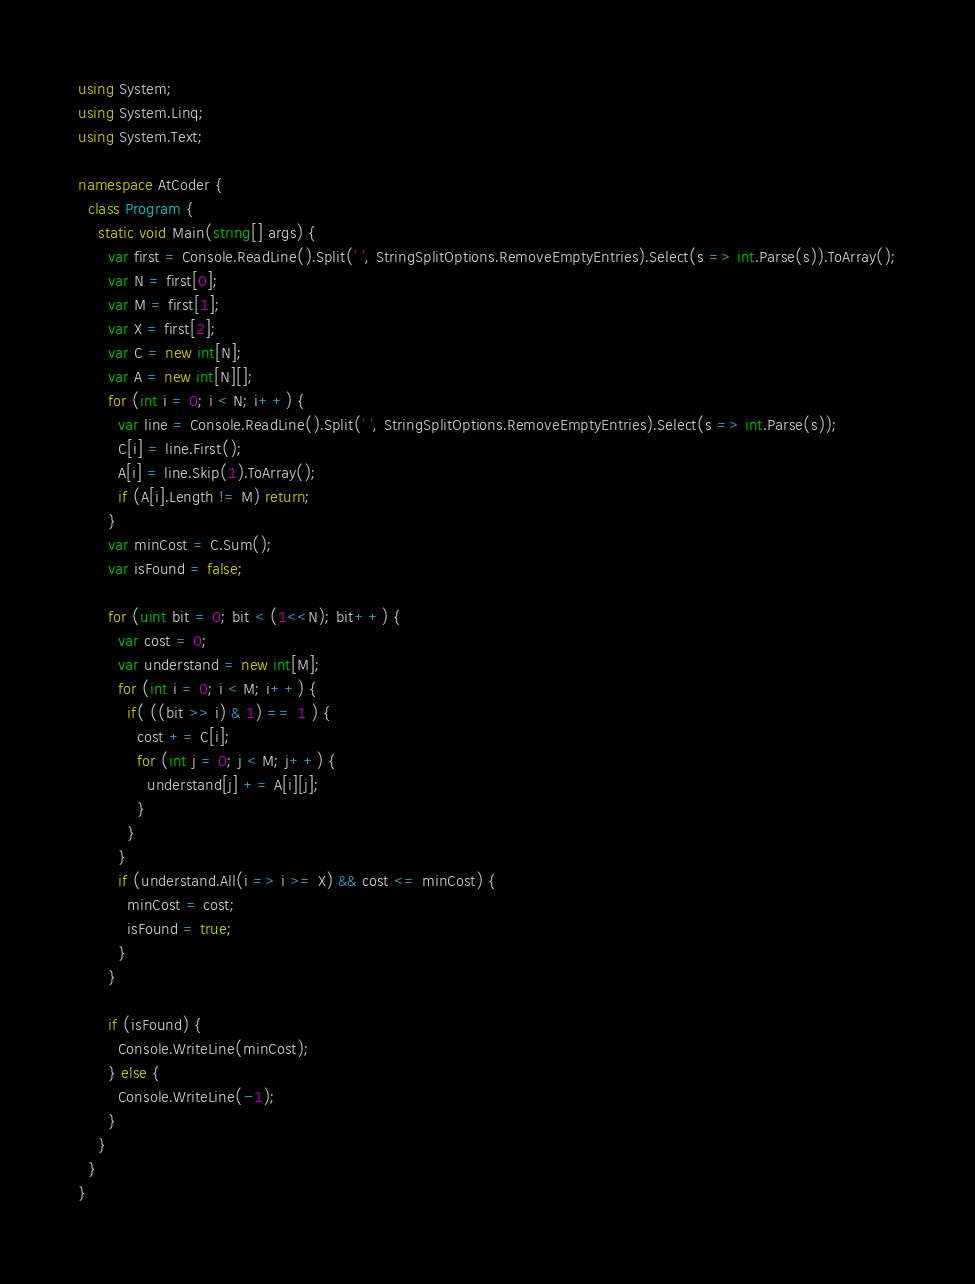<code> <loc_0><loc_0><loc_500><loc_500><_C#_>using System;
using System.Linq;
using System.Text;

namespace AtCoder {
  class Program {
    static void Main(string[] args) {
      var first = Console.ReadLine().Split(' ', StringSplitOptions.RemoveEmptyEntries).Select(s => int.Parse(s)).ToArray();
      var N = first[0];
      var M = first[1];
      var X = first[2];
      var C = new int[N];
      var A = new int[N][];
      for (int i = 0; i < N; i++) { 
        var line = Console.ReadLine().Split(' ', StringSplitOptions.RemoveEmptyEntries).Select(s => int.Parse(s));
        C[i] = line.First();
        A[i] = line.Skip(1).ToArray();
        if (A[i].Length != M) return;
      }
      var minCost = C.Sum();
      var isFound = false;

      for (uint bit = 0; bit < (1<<N); bit++) {
        var cost = 0;
        var understand = new int[M];
        for (int i = 0; i < M; i++) {
          if( ((bit >> i) & 1) == 1 ) {
            cost += C[i];
            for (int j = 0; j < M; j++) {
              understand[j] += A[i][j];
            }
          }
        }
        if (understand.All(i => i >= X) && cost <= minCost) {
          minCost = cost;
          isFound = true;
        }
      }

      if (isFound) {
        Console.WriteLine(minCost);
      } else {
        Console.WriteLine(-1);
      }
    }
  }
}
</code> 